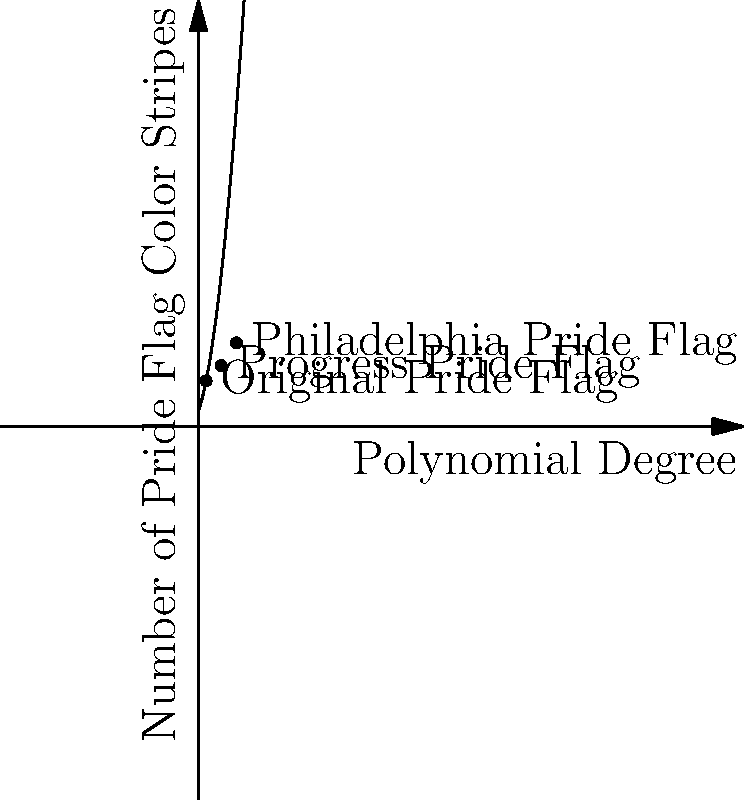The graph shows the relationship between the degree of a polynomial and the number of color stripes in various pride flags. If this trend continues, how many color stripes would a pride flag represented by a 4th-degree polynomial have? To solve this problem, we need to follow these steps:

1. Observe the given data points:
   - Original Pride Flag: (1, 6)
   - Progress Pride Flag: (3, 8)
   - Philadelphia Pride Flag: (5, 11)

2. Recognize that the relationship appears to follow a quadratic pattern (polynomial of degree 2).

3. The general form of a quadratic equation is $f(x) = ax^2 + bx + c$, where $x$ represents the polynomial degree and $f(x)$ represents the number of color stripes.

4. We can approximate the equation using the given points. The curve passes through (1, 6), (3, 8), and (5, 11).

5. Without exact calculations, we can estimate that the equation is close to $f(x) = x^2 + 3x + 2$.

6. To find the number of stripes for a 4th-degree polynomial, we substitute $x = 4$ into our estimated equation:

   $f(4) = 4^2 + 3(4) + 2 = 16 + 12 + 2 = 30$

7. However, since we're dealing with pride flags, we need to round to the nearest whole number of stripes.

Therefore, a pride flag represented by a 4th-degree polynomial would have approximately 10 color stripes.
Answer: 10 stripes 